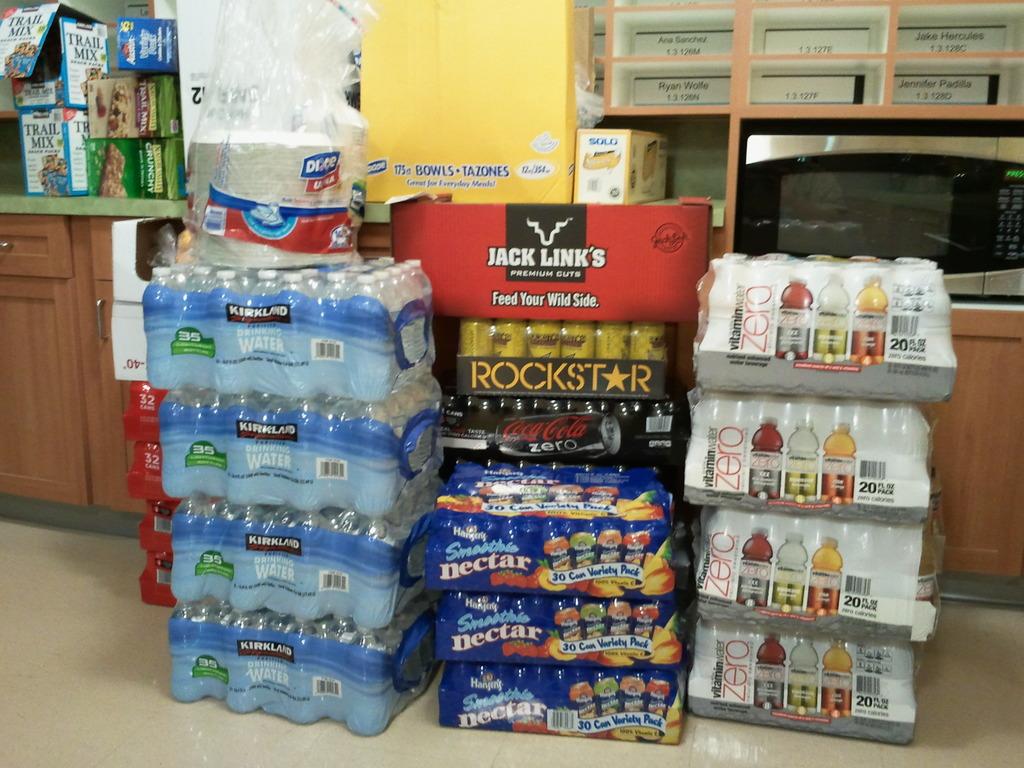What is the brand of beef jerky here?
Your response must be concise. Jack link's. What type of sports drink is in the four cases on the right?
Your response must be concise. Vitamin water. 